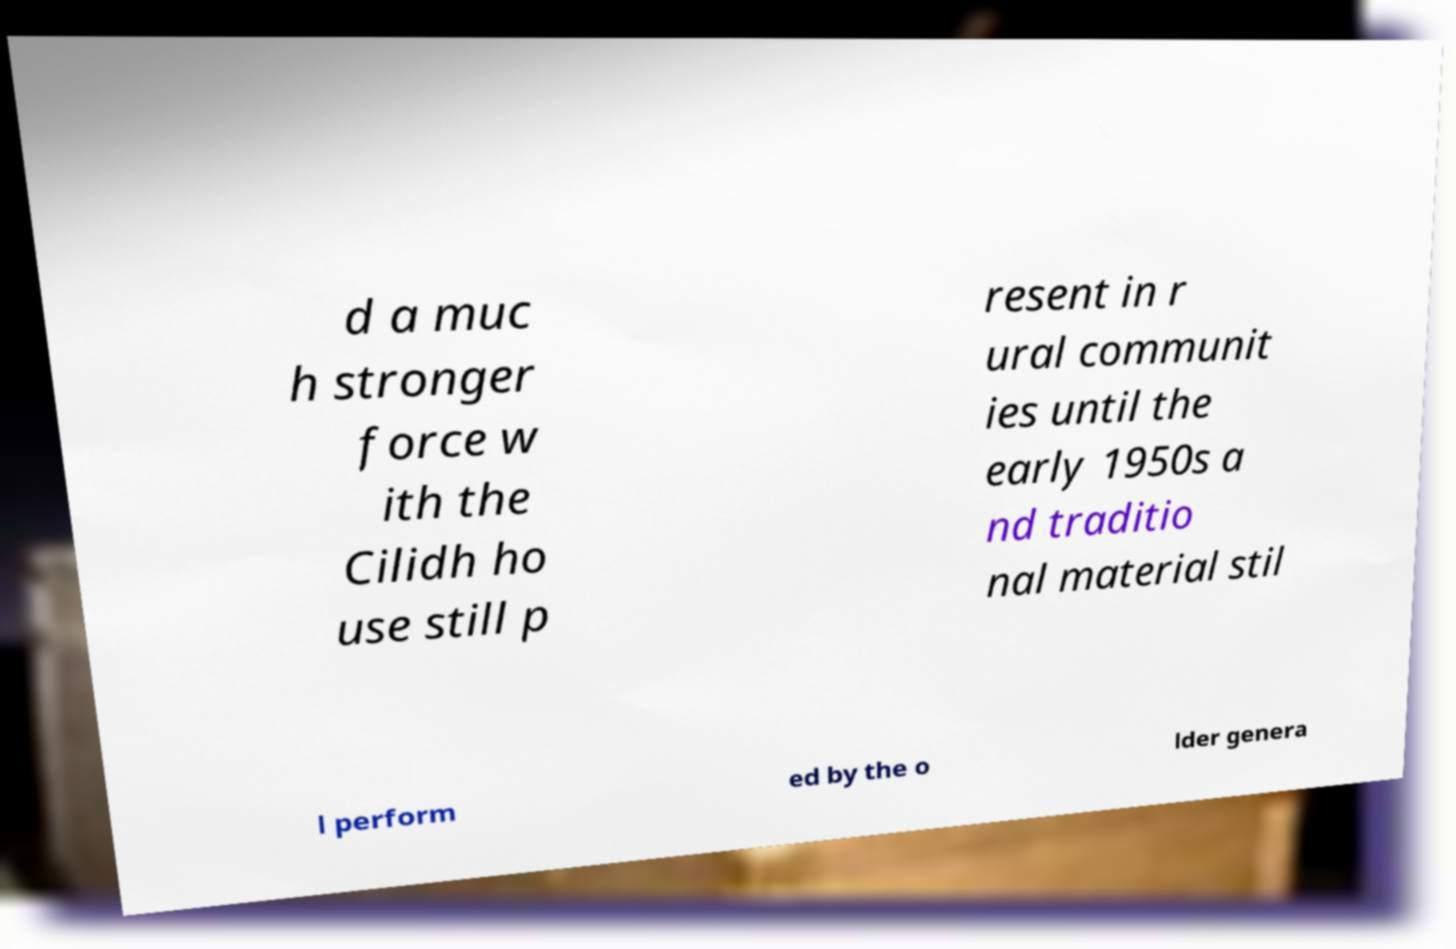Can you accurately transcribe the text from the provided image for me? d a muc h stronger force w ith the Cilidh ho use still p resent in r ural communit ies until the early 1950s a nd traditio nal material stil l perform ed by the o lder genera 